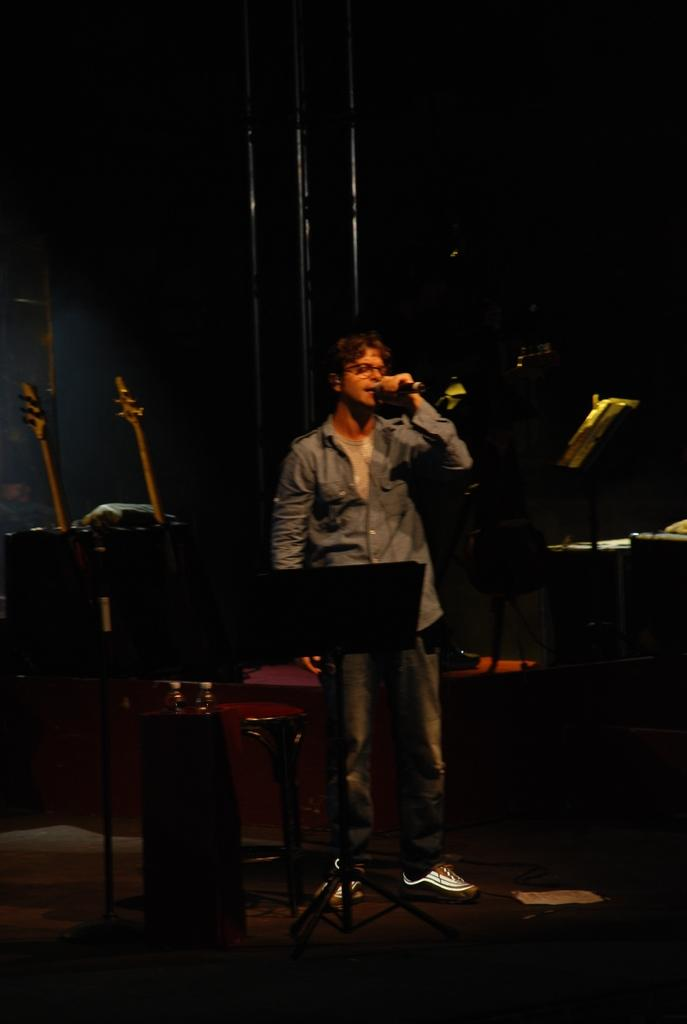What is the main subject of the image? The main subject of the image is a man. What is the man wearing on his upper body? The man is wearing a blue shirt. What type of clothing is the man wearing on his lower body? The man is wearing pants. What type of footwear is the man wearing? The man is wearing shoes. What is the man doing in the image? The man is standing and holding a microphone. What else can be seen in the image besides the man? There are musical instruments in the image. What type of humor is the man displaying in the image? There is no indication of humor in the image; the man is simply standing and holding a microphone. 